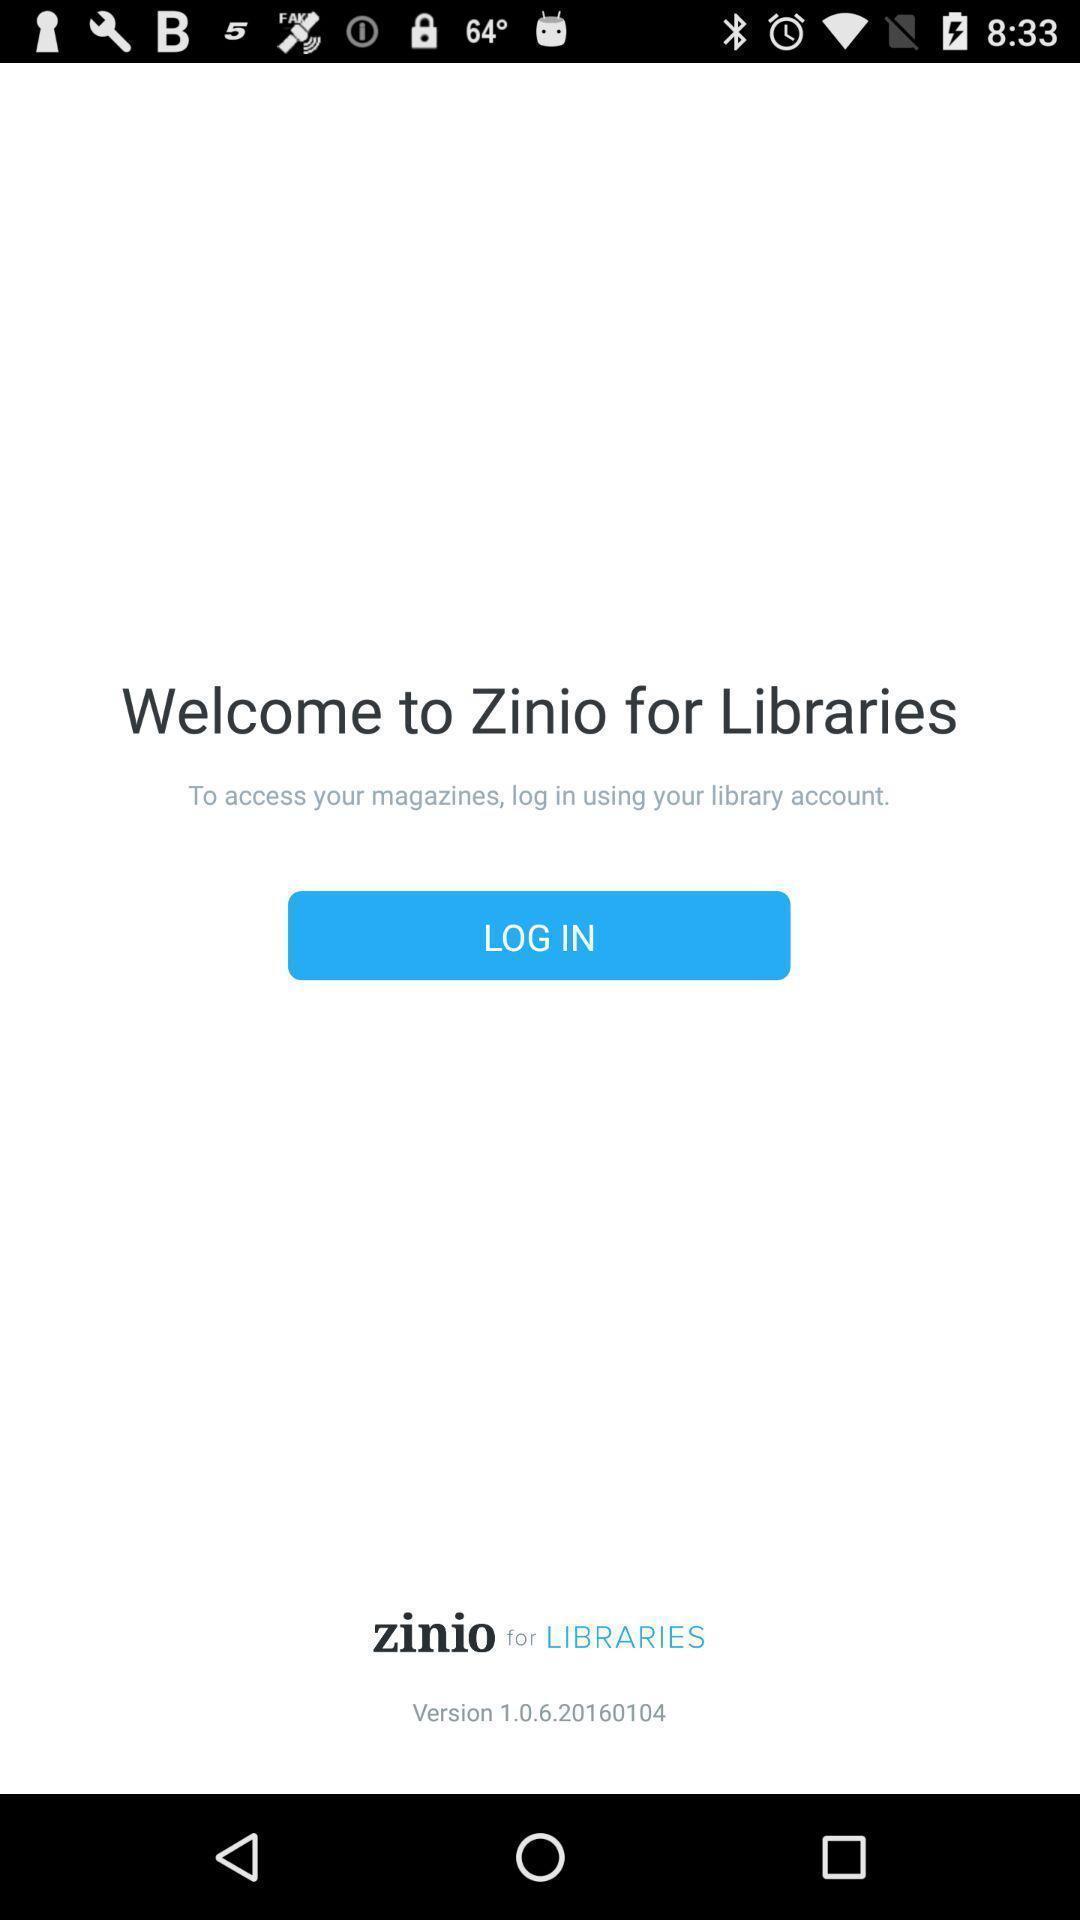Provide a description of this screenshot. Welcome page. 